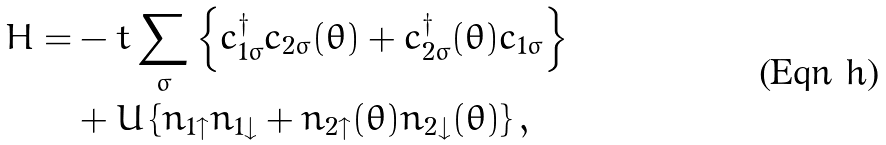Convert formula to latex. <formula><loc_0><loc_0><loc_500><loc_500>H = & - t \sum _ { \sigma } \left \{ c _ { 1 \sigma } ^ { \dag } c _ { 2 \sigma } ( \theta ) + c _ { 2 \sigma } ^ { \dag } ( \theta ) c _ { 1 \sigma } \right \} \\ & + U \left \{ n _ { 1 \uparrow } n _ { 1 \downarrow } + n _ { 2 \uparrow } ( \theta ) n _ { 2 \downarrow } ( \theta ) \right \} ,</formula> 